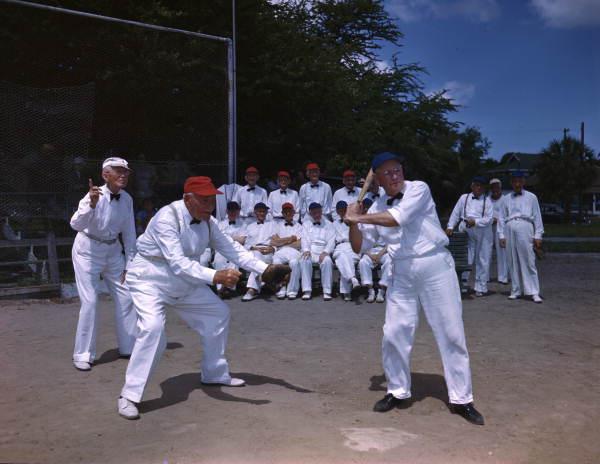Are they in the middle of playing a game?
Keep it brief. Yes. How many red hats are shown?
Give a very brief answer. 6. What color suits are the men wearing?
Short answer required. White. What kind of game are the playing?
Answer briefly. Baseball. 